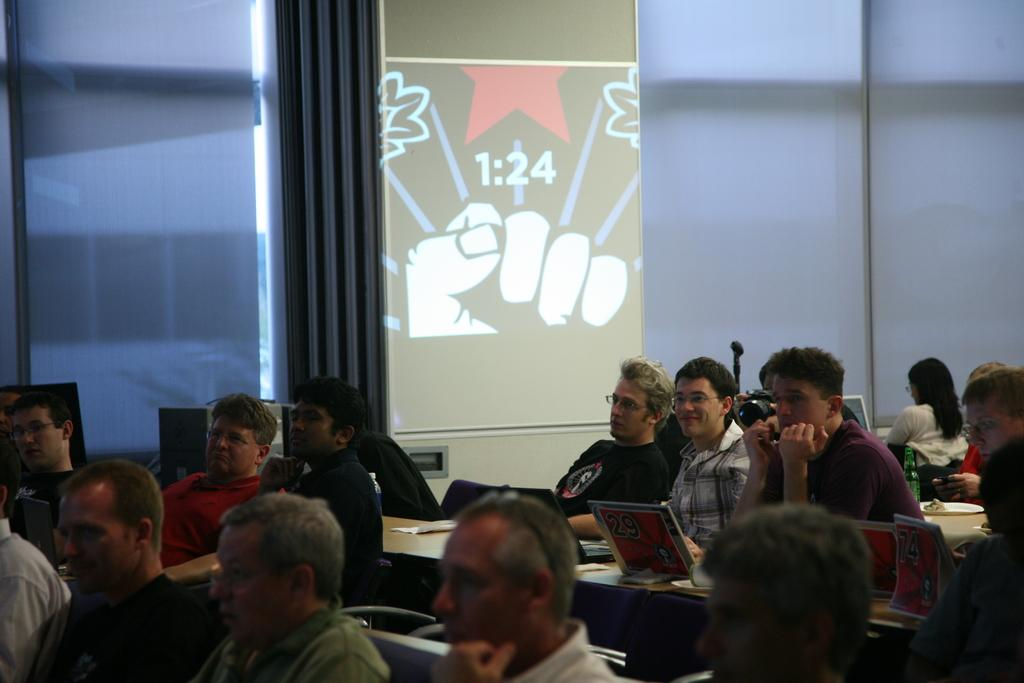What are the people in the image doing? The people in the image are sitting. What electronic devices can be seen in the image? There are laptops and a monitor visible in the image. Is there any text or writing present in the image? Yes, there is text or writing visible in the image. What type of force is being applied to the stove in the image? There is no stove present in the image, so no force is being applied to it. 